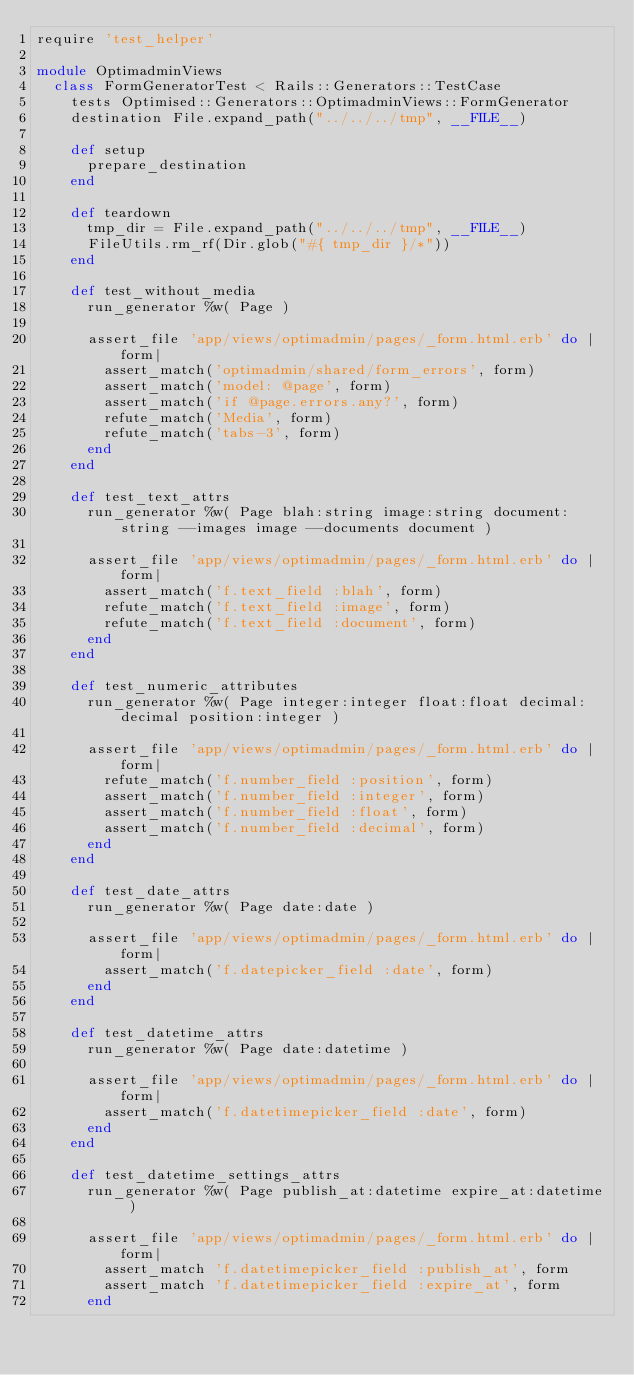<code> <loc_0><loc_0><loc_500><loc_500><_Ruby_>require 'test_helper'

module OptimadminViews
  class FormGeneratorTest < Rails::Generators::TestCase
    tests Optimised::Generators::OptimadminViews::FormGenerator
    destination File.expand_path("../../../tmp", __FILE__)

    def setup
      prepare_destination
    end

    def teardown
      tmp_dir = File.expand_path("../../../tmp", __FILE__)
      FileUtils.rm_rf(Dir.glob("#{ tmp_dir }/*"))
    end

    def test_without_media
      run_generator %w( Page )

      assert_file 'app/views/optimadmin/pages/_form.html.erb' do |form|
        assert_match('optimadmin/shared/form_errors', form)
        assert_match('model: @page', form)
        assert_match('if @page.errors.any?', form)
        refute_match('Media', form)
        refute_match('tabs-3', form)
      end
    end

    def test_text_attrs
      run_generator %w( Page blah:string image:string document:string --images image --documents document )

      assert_file 'app/views/optimadmin/pages/_form.html.erb' do |form|
        assert_match('f.text_field :blah', form)
        refute_match('f.text_field :image', form)
        refute_match('f.text_field :document', form)
      end
    end

    def test_numeric_attributes
      run_generator %w( Page integer:integer float:float decimal:decimal position:integer )

      assert_file 'app/views/optimadmin/pages/_form.html.erb' do |form|
        refute_match('f.number_field :position', form)
        assert_match('f.number_field :integer', form)
        assert_match('f.number_field :float', form)
        assert_match('f.number_field :decimal', form)
      end
    end

    def test_date_attrs
      run_generator %w( Page date:date )

      assert_file 'app/views/optimadmin/pages/_form.html.erb' do |form|
        assert_match('f.datepicker_field :date', form)
      end
    end

    def test_datetime_attrs
      run_generator %w( Page date:datetime )

      assert_file 'app/views/optimadmin/pages/_form.html.erb' do |form|
        assert_match('f.datetimepicker_field :date', form)
      end
    end

    def test_datetime_settings_attrs
      run_generator %w( Page publish_at:datetime expire_at:datetime )

      assert_file 'app/views/optimadmin/pages/_form.html.erb' do |form|
        assert_match 'f.datetimepicker_field :publish_at', form
        assert_match 'f.datetimepicker_field :expire_at', form
      end</code> 